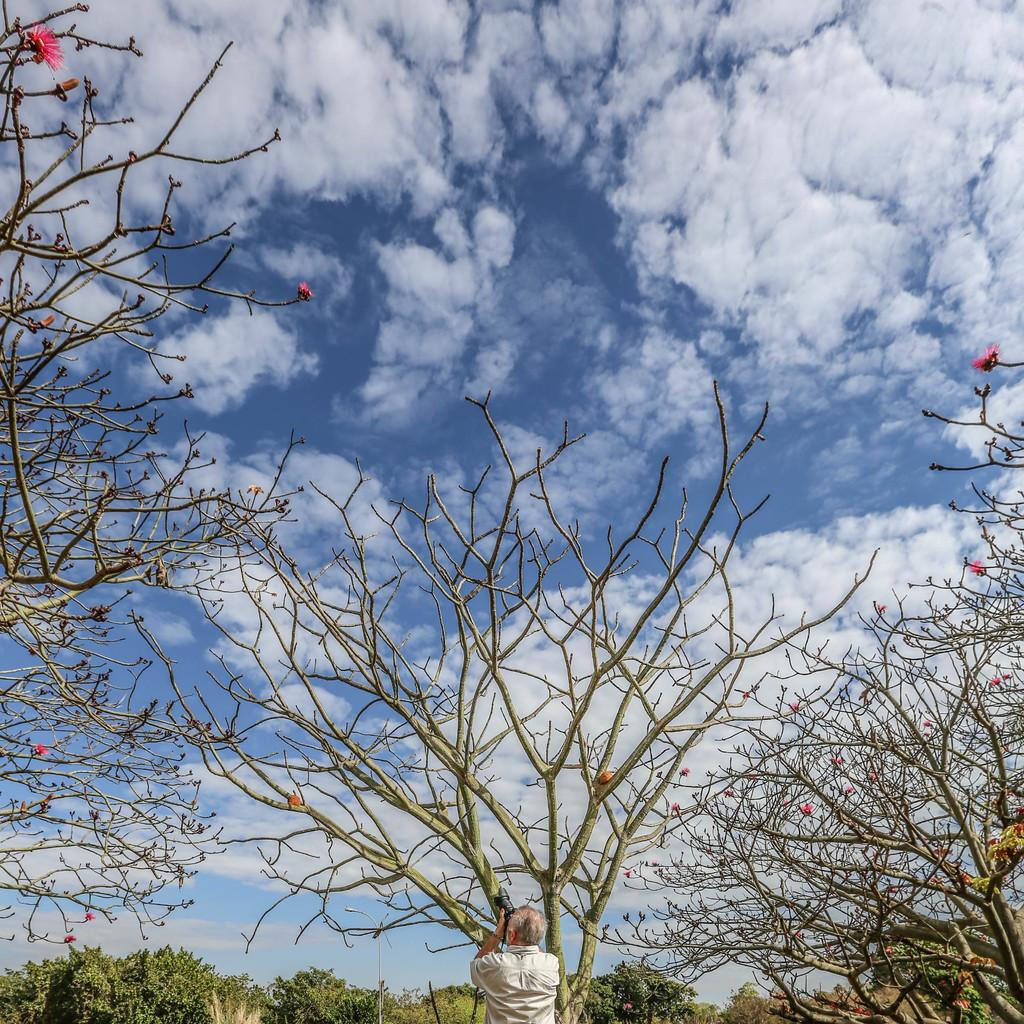Who is present in the image? There is a person in the image. What is the person doing in the image? The person is holding a camera and taking a photo. What can be seen in the background of the image? There are trees, flowers, and clouds in the sky in the image. What type of crime is being committed in the image? There is no crime being committed in the image; the person is simply taking a photo. How does the person feel shame in the image? There is no indication of shame in the image; the person is focused on taking a photo. 